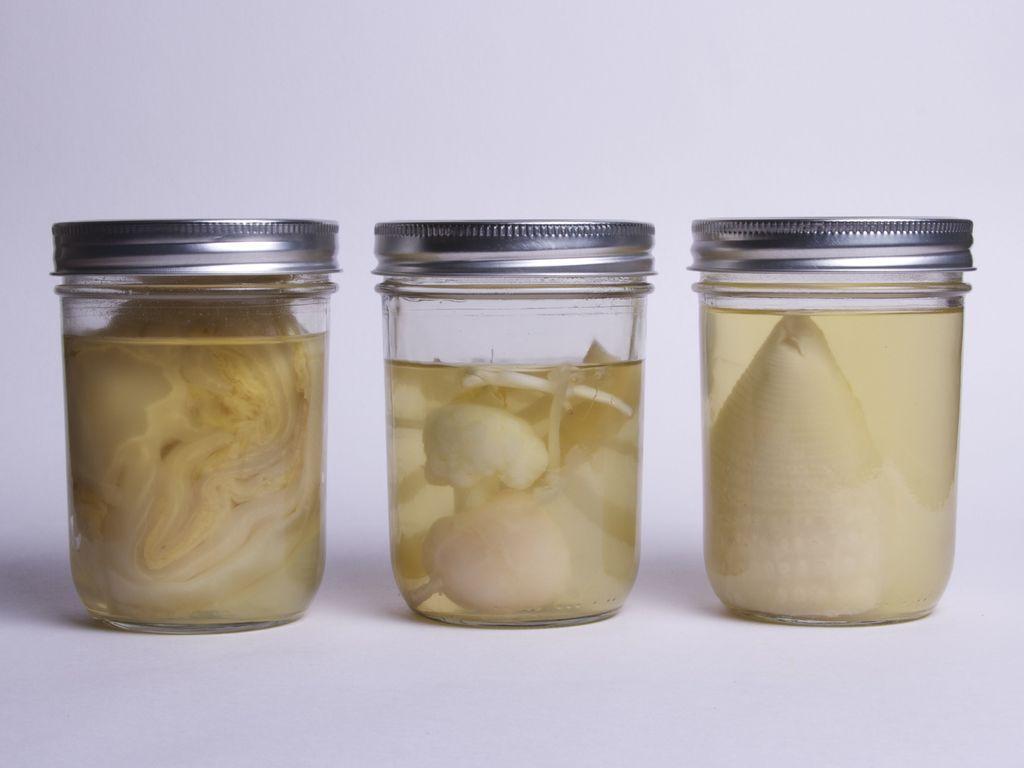Please provide a concise description of this image. In this image there are three jars. There are liquid like substances in the jar. The background is white. 